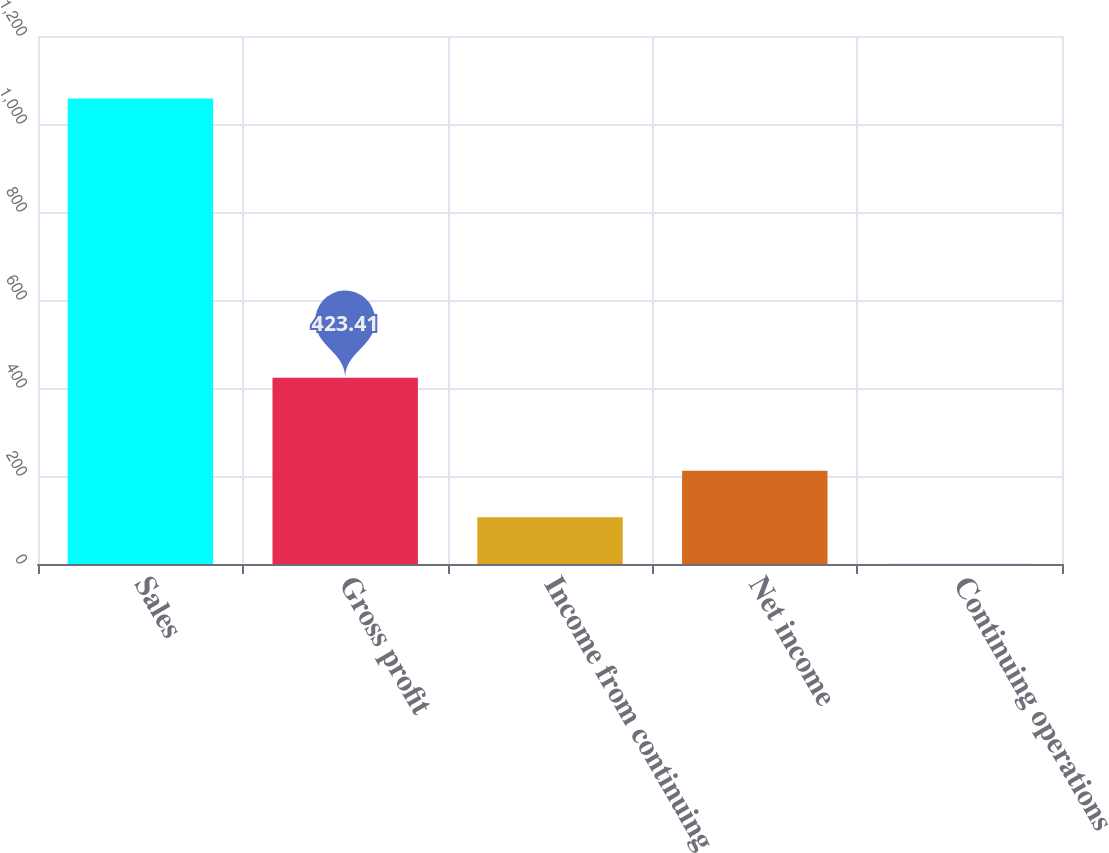<chart> <loc_0><loc_0><loc_500><loc_500><bar_chart><fcel>Sales<fcel>Gross profit<fcel>Income from continuing<fcel>Net income<fcel>Continuing operations<nl><fcel>1058.1<fcel>423.41<fcel>106.07<fcel>211.85<fcel>0.29<nl></chart> 